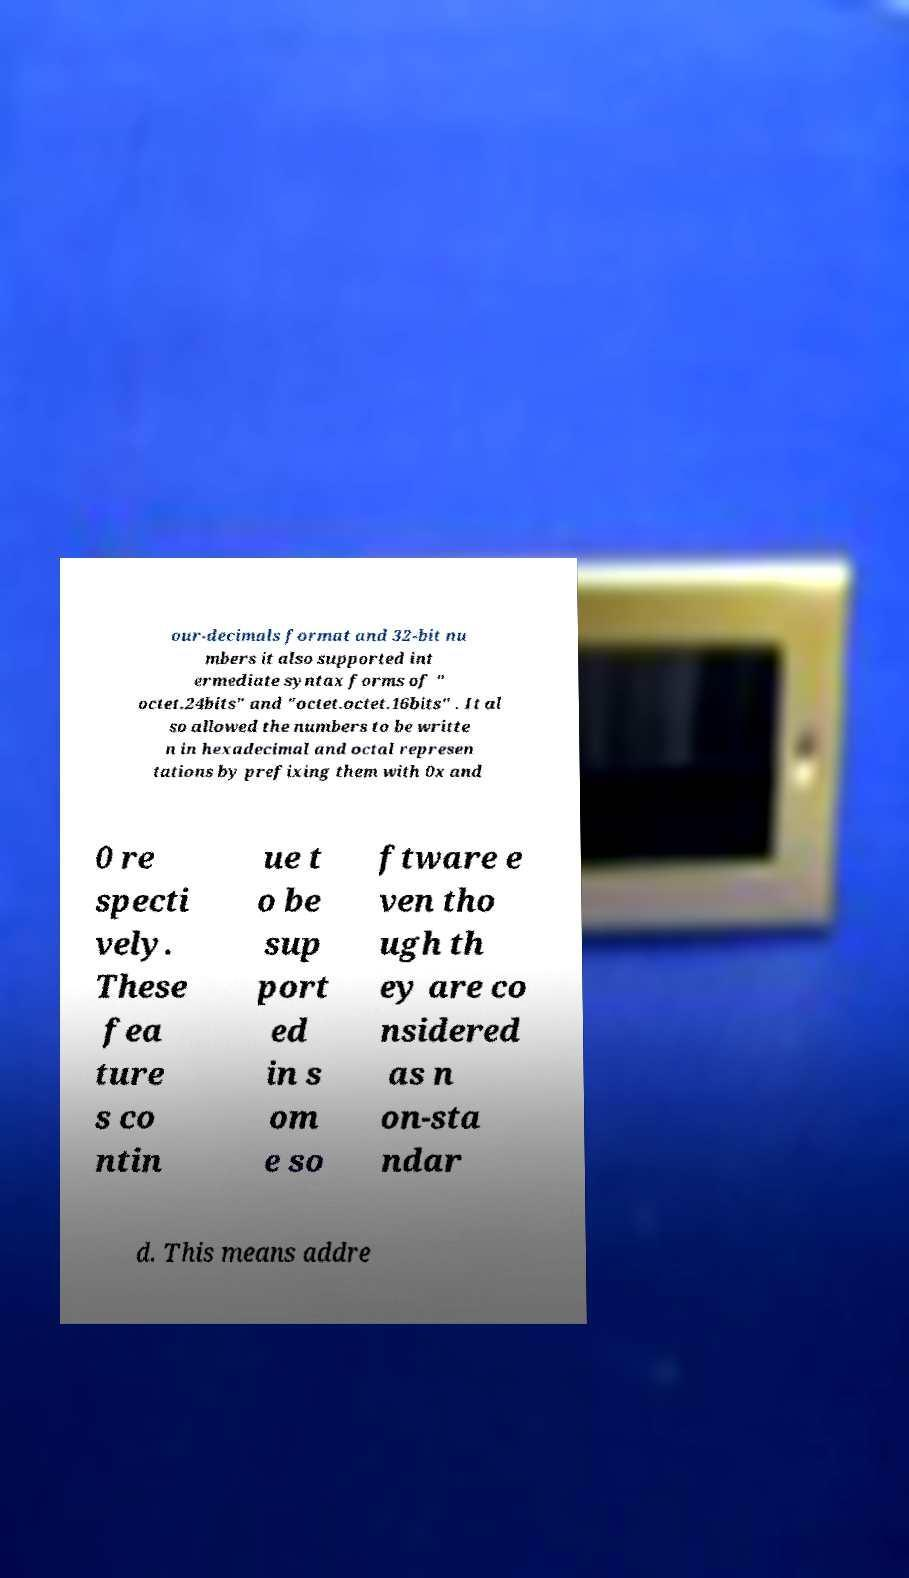Can you accurately transcribe the text from the provided image for me? our-decimals format and 32-bit nu mbers it also supported int ermediate syntax forms of " octet.24bits" and "octet.octet.16bits" . It al so allowed the numbers to be writte n in hexadecimal and octal represen tations by prefixing them with 0x and 0 re specti vely. These fea ture s co ntin ue t o be sup port ed in s om e so ftware e ven tho ugh th ey are co nsidered as n on-sta ndar d. This means addre 